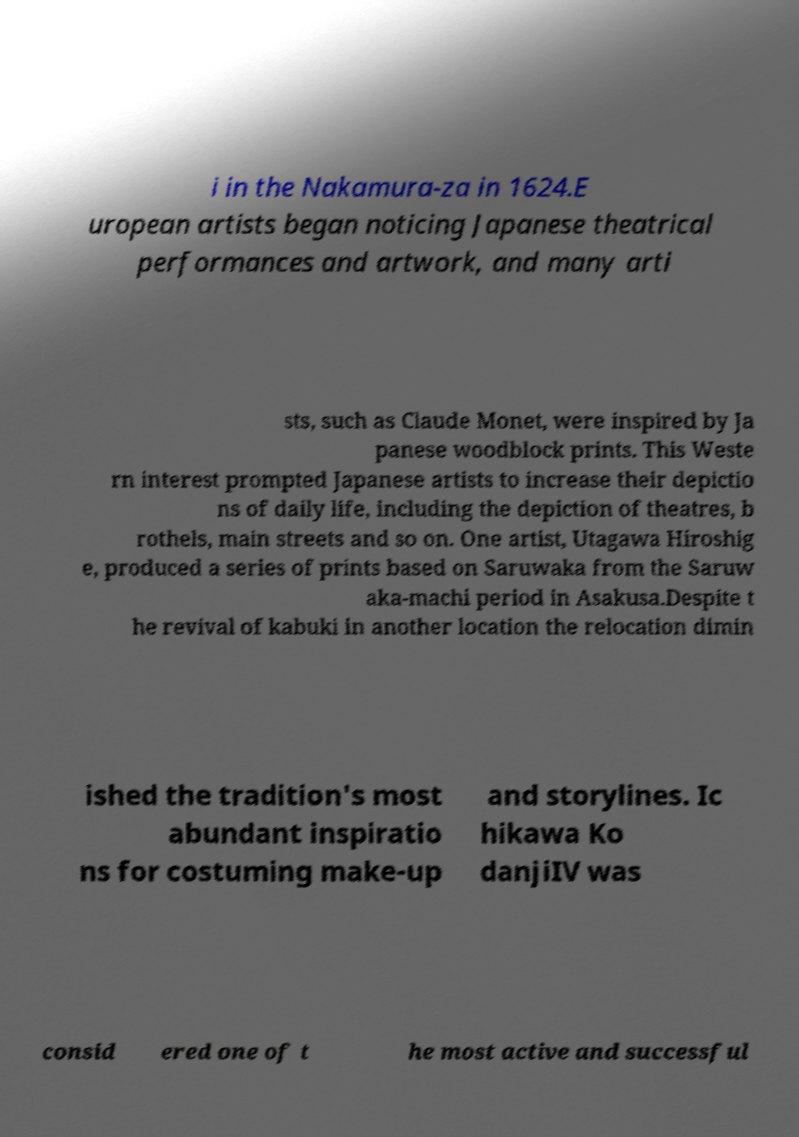Can you accurately transcribe the text from the provided image for me? i in the Nakamura-za in 1624.E uropean artists began noticing Japanese theatrical performances and artwork, and many arti sts, such as Claude Monet, were inspired by Ja panese woodblock prints. This Weste rn interest prompted Japanese artists to increase their depictio ns of daily life, including the depiction of theatres, b rothels, main streets and so on. One artist, Utagawa Hiroshig e, produced a series of prints based on Saruwaka from the Saruw aka-machi period in Asakusa.Despite t he revival of kabuki in another location the relocation dimin ished the tradition's most abundant inspiratio ns for costuming make-up and storylines. Ic hikawa Ko danjiIV was consid ered one of t he most active and successful 